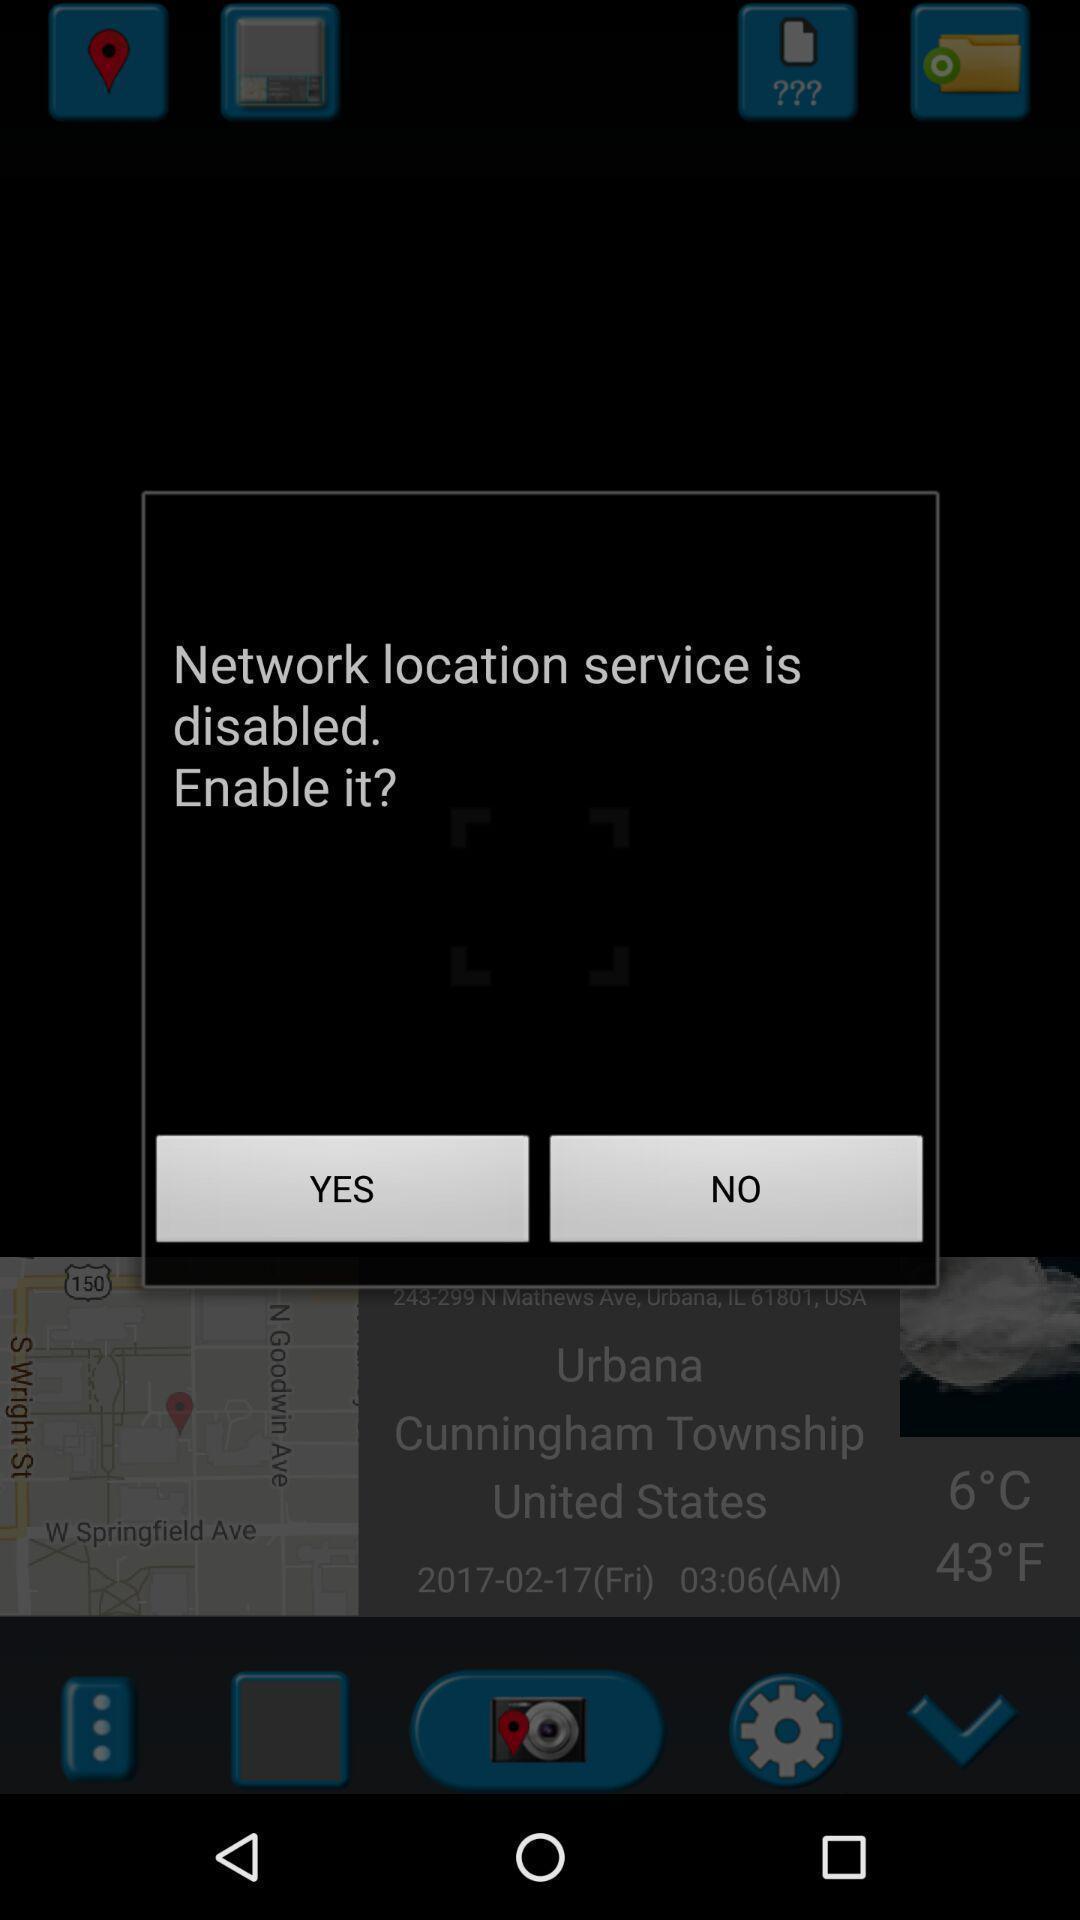Give me a summary of this screen capture. Pop-up to enable a network location service. 